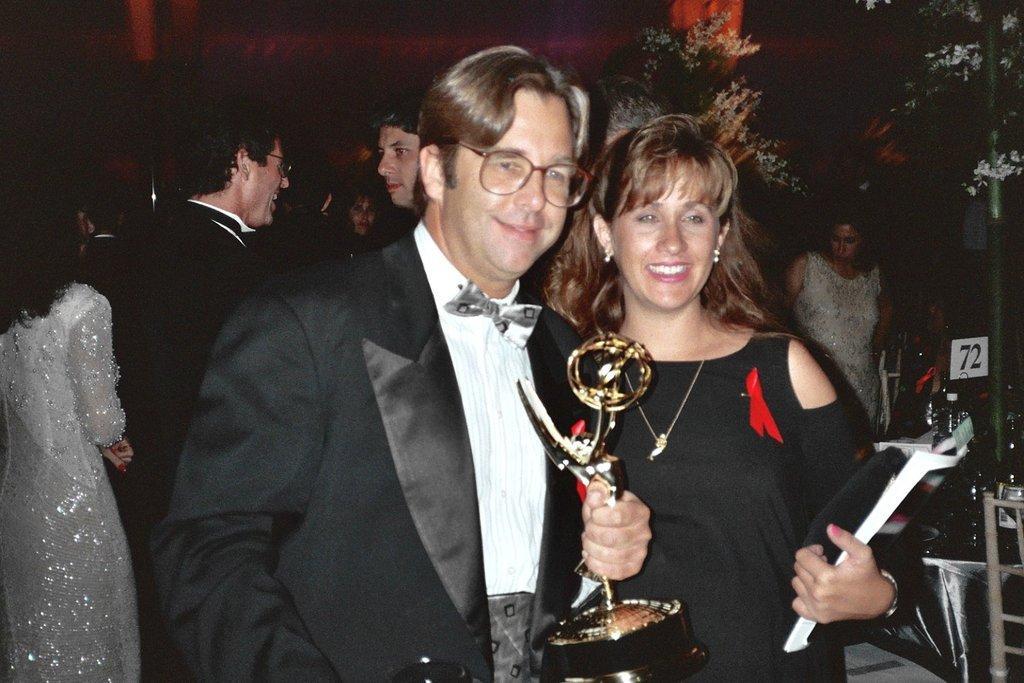Could you give a brief overview of what you see in this image? In this image, in the middle, we can see two people man and woman are standing and holding some object in their hands. In the background, we can see a group of people. In the right corner, we can see a chair and table. On the table, we can see some bottles. On the right side, we can also see another table. In the background, we can see some plants and black color. 